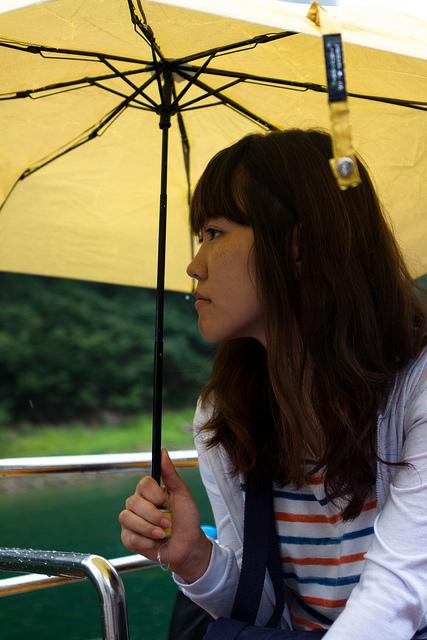When the rain stops how will this umbrella be stored? folded 